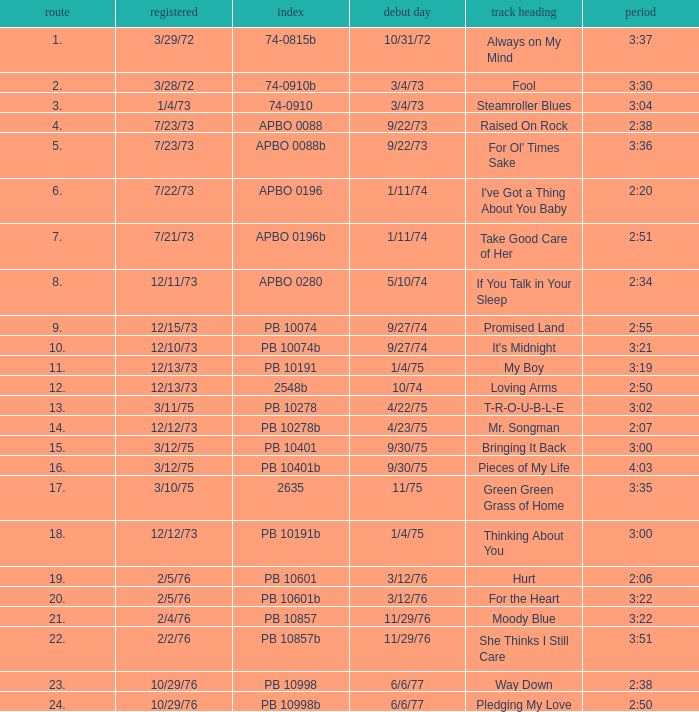Tell me the track that has the catalogue of apbo 0280 8.0. 